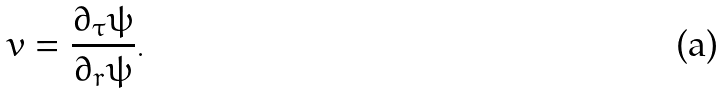Convert formula to latex. <formula><loc_0><loc_0><loc_500><loc_500>v = \frac { \partial _ { \tau } \psi } { \partial _ { r } \psi } .</formula> 